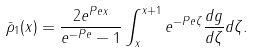Convert formula to latex. <formula><loc_0><loc_0><loc_500><loc_500>\bar { \rho } _ { 1 } ( x ) = \frac { 2 e ^ { P e x } } { e ^ { - P e } - 1 } \int _ { x } ^ { x + 1 } e ^ { - P e \zeta } \frac { d g } { d \zeta } d \zeta .</formula> 